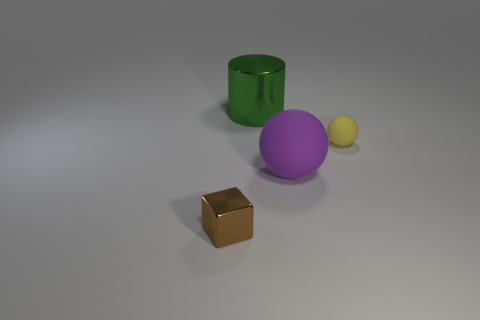What is the size of the rubber object to the right of the big object that is in front of the green shiny object?
Offer a very short reply. Small. There is a metallic thing that is on the right side of the brown metallic cube; does it have the same size as the purple matte sphere?
Your answer should be compact. Yes. Are there more brown shiny things that are in front of the tiny matte object than large objects that are right of the large metallic cylinder?
Make the answer very short. No. What is the shape of the object that is in front of the shiny cylinder and on the left side of the big purple object?
Provide a short and direct response. Cube. There is a metallic thing that is to the right of the small metal object; what shape is it?
Ensure brevity in your answer.  Cylinder. What size is the purple sphere that is in front of the small thing that is on the right side of the thing that is to the left of the shiny cylinder?
Give a very brief answer. Large. Is the shape of the green object the same as the tiny brown thing?
Offer a very short reply. No. There is a thing that is left of the large purple matte ball and on the right side of the tiny brown thing; what size is it?
Provide a short and direct response. Large. What material is the other purple object that is the same shape as the small matte thing?
Your answer should be compact. Rubber. The tiny object that is on the left side of the rubber ball that is behind the big purple sphere is made of what material?
Offer a very short reply. Metal. 